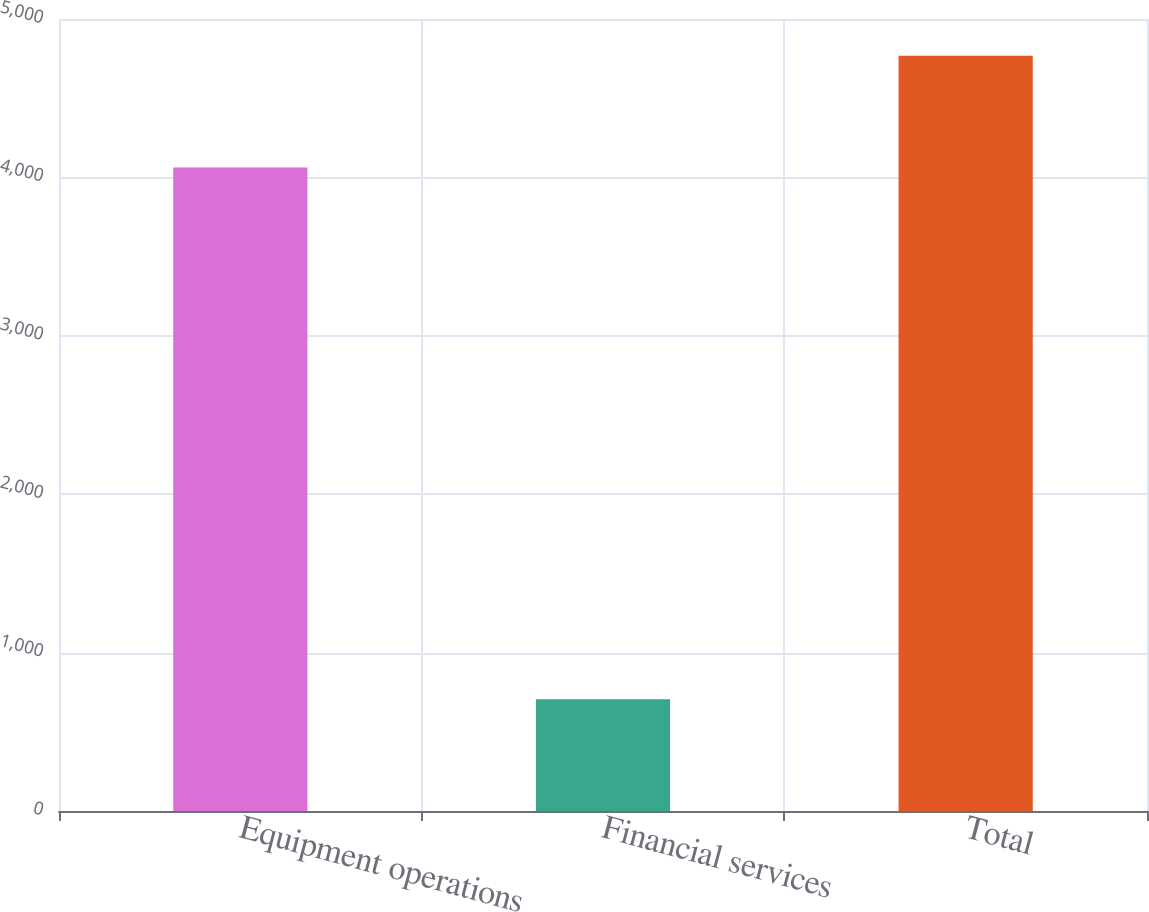<chart> <loc_0><loc_0><loc_500><loc_500><bar_chart><fcel>Equipment operations<fcel>Financial services<fcel>Total<nl><fcel>4062<fcel>706<fcel>4768<nl></chart> 